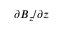Convert formula to latex. <formula><loc_0><loc_0><loc_500><loc_500>\partial B _ { z } / \partial z</formula> 